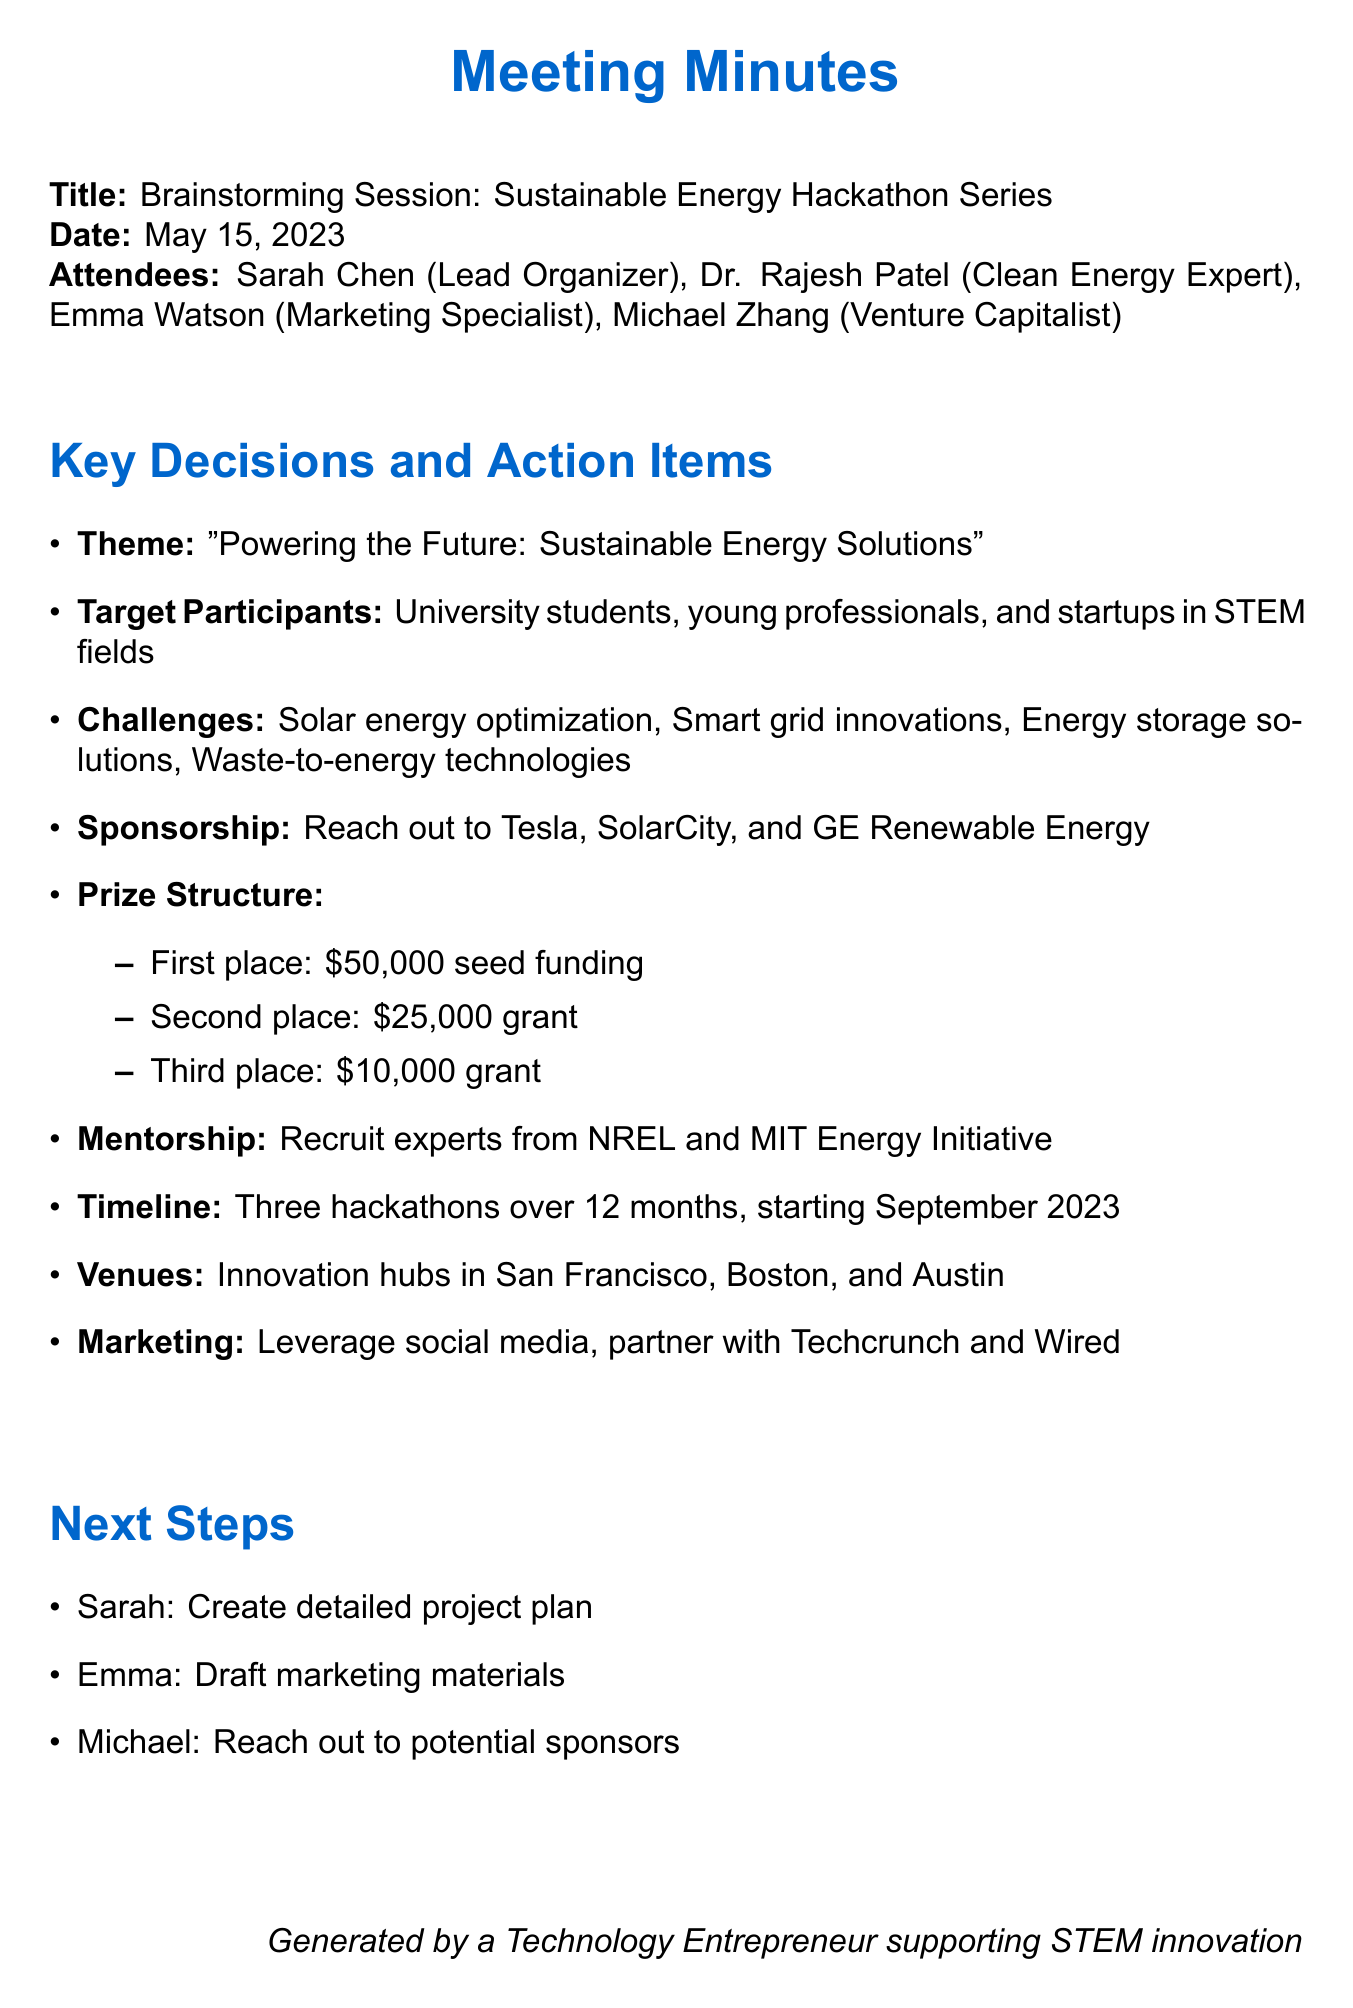What is the hackathon theme? The theme decided for the hackathon is mentioned in the document under "Hackathon Theme."
Answer: Powering the Future: Sustainable Energy Solutions Who is the lead organizer of the meeting? The document lists the attendees and their roles, identifying the lead organizer.
Answer: Sarah Chen What is the prize for second place? The document outlines the prize structure, specifying the amount for second place.
Answer: $25,000 grant What are the venues for the hackathons? The venues are specifically mentioned in the document under the "Venue" section.
Answer: San Francisco, Boston, and Austin How many hackathons are planned over 12 months? The timeline indicates the number of hackathons planned within a specific timeframe.
Answer: Three hackathons Which organizations are potential sponsors? The document lists organizations targeted for sponsorship under the "Sponsorship and Partnerships" section.
Answer: Tesla, SolarCity, GE Renewable Energy What is the next step for Emma? The next steps for individuals are outlined in the document, indicating Emma's specific task.
Answer: Draft marketing materials What kind of participants are targeted? The document identifies the target participants for the hackathon series.
Answer: University students, young professionals, and startups in STEM fields Which programs are to be recruited for mentorship? The document specifies where the mentorship recruits are to come from.
Answer: National Renewable Energy Laboratory (NREL) and MIT Energy Initiative 